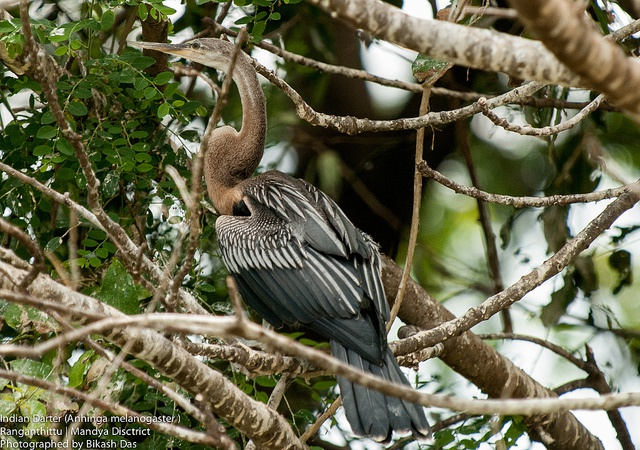Describe the objects in this image and their specific colors. I can see a bird in lightgray, black, gray, and darkgray tones in this image. 